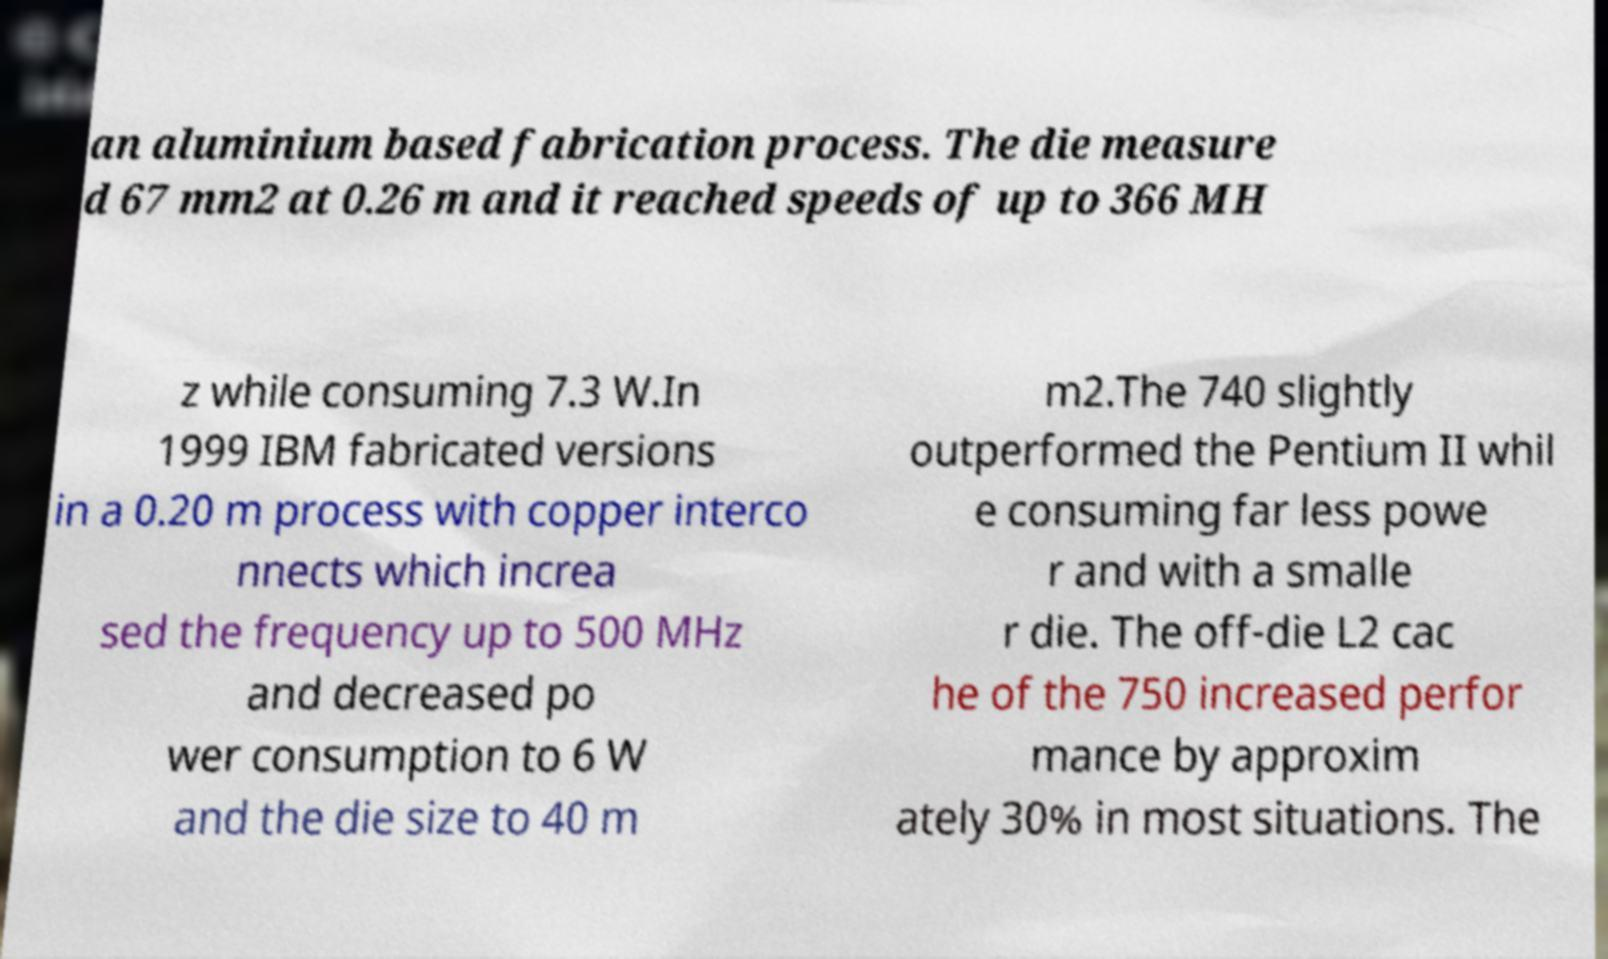I need the written content from this picture converted into text. Can you do that? an aluminium based fabrication process. The die measure d 67 mm2 at 0.26 m and it reached speeds of up to 366 MH z while consuming 7.3 W.In 1999 IBM fabricated versions in a 0.20 m process with copper interco nnects which increa sed the frequency up to 500 MHz and decreased po wer consumption to 6 W and the die size to 40 m m2.The 740 slightly outperformed the Pentium II whil e consuming far less powe r and with a smalle r die. The off-die L2 cac he of the 750 increased perfor mance by approxim ately 30% in most situations. The 